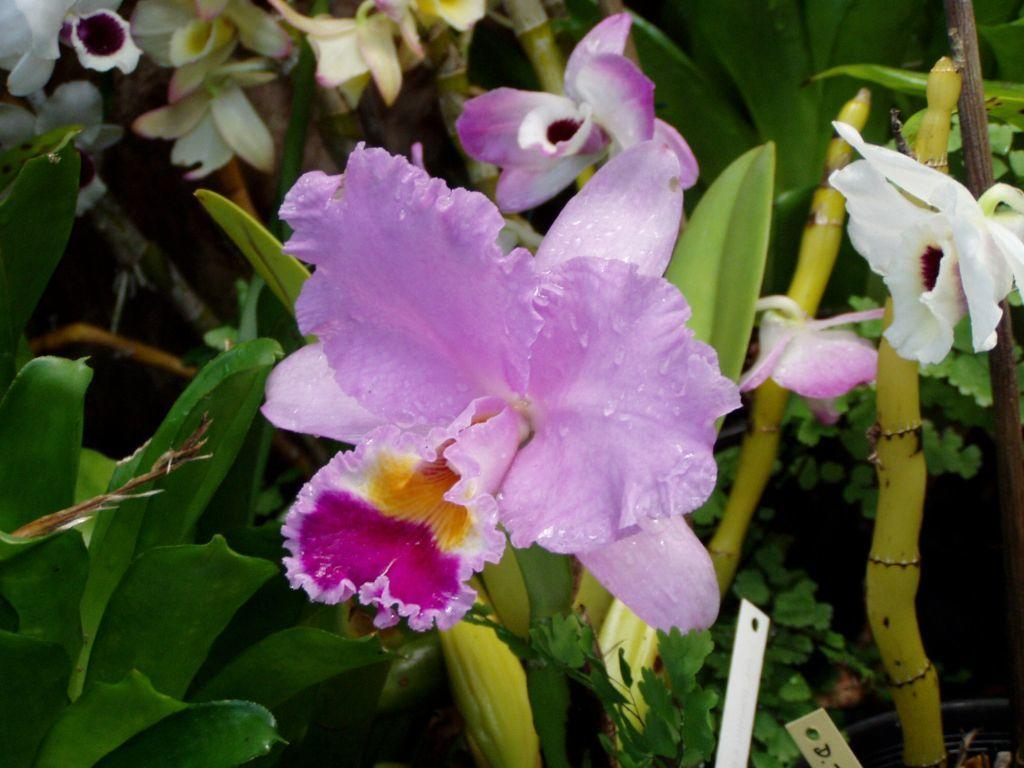What type of plant life can be seen in the image? There are flowers and leaves in the image. Can you describe the appearance of the flowers? Unfortunately, the specific appearance of the flowers cannot be determined from the provided facts. What else is present in the image besides the flowers and leaves? The provided facts do not mention any other objects or elements in the image. What type of building can be seen in the background of the image? There is no mention of a building in the provided facts, so it cannot be determined if one is present in the image. 